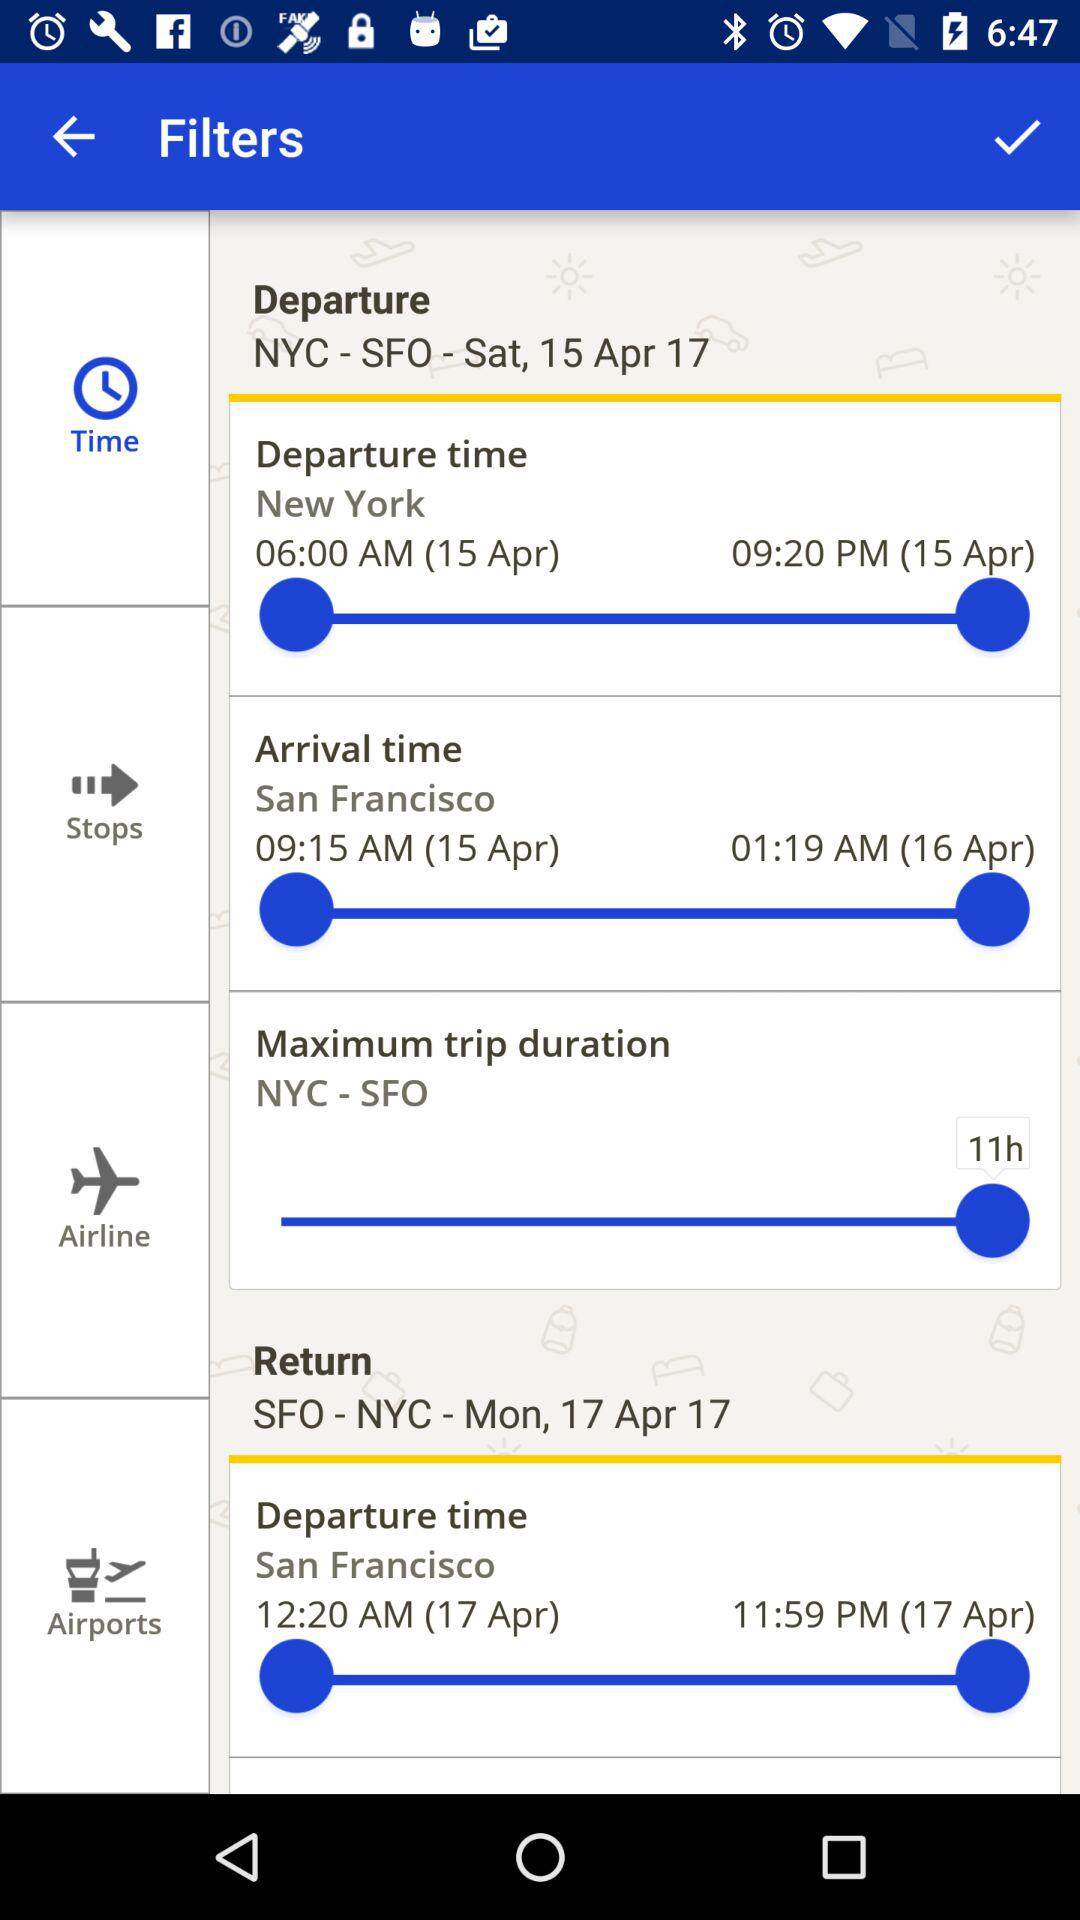How many hours is the maximum trip duration?
Answer the question using a single word or phrase. 11h 